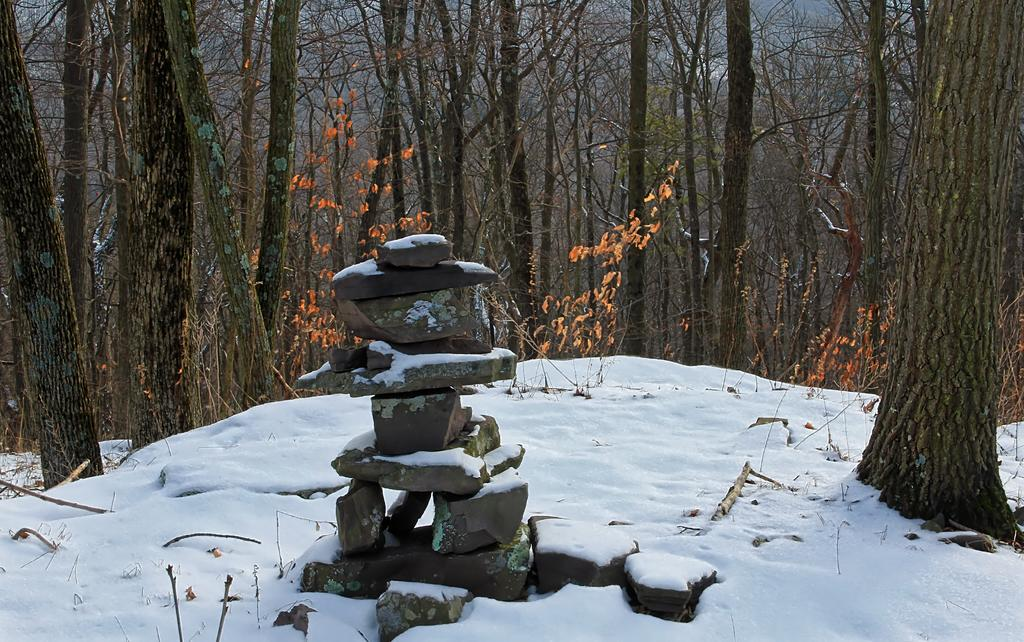What is the main subject of the image? The main subject of the image is rocks arranged one on the other. What can be seen in the background of the image? There are trees visible in the image. What is the weather condition in the image? There is snow in the image, indicating a cold or wintry condition. What type of eggs can be seen in the image? There are no eggs present in the image; it features rocks arranged one on the other with trees in the background and snow as the weather condition. 